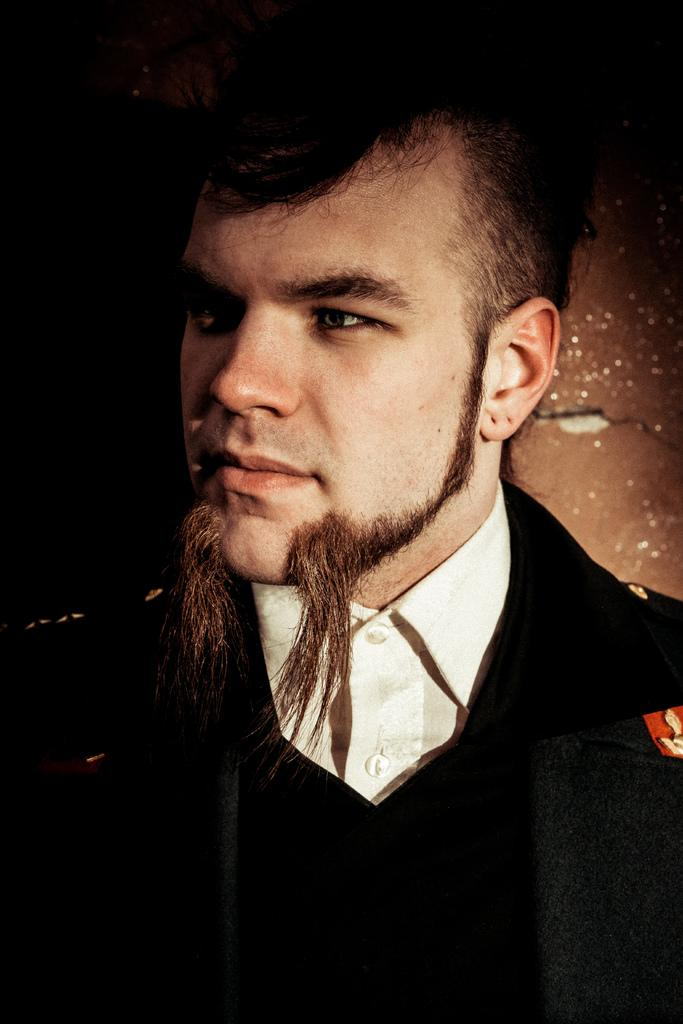What is present in the image? There is a person in the image. Can you describe the person's appearance? The person has a beard and is wearing a black color suit. What type of sweater is the person wearing in the image? The person is not wearing a sweater in the image; they are wearing a black color suit. How many men are present in the image? There is only one person present in the image, and they are not identified as a man or a woman. 